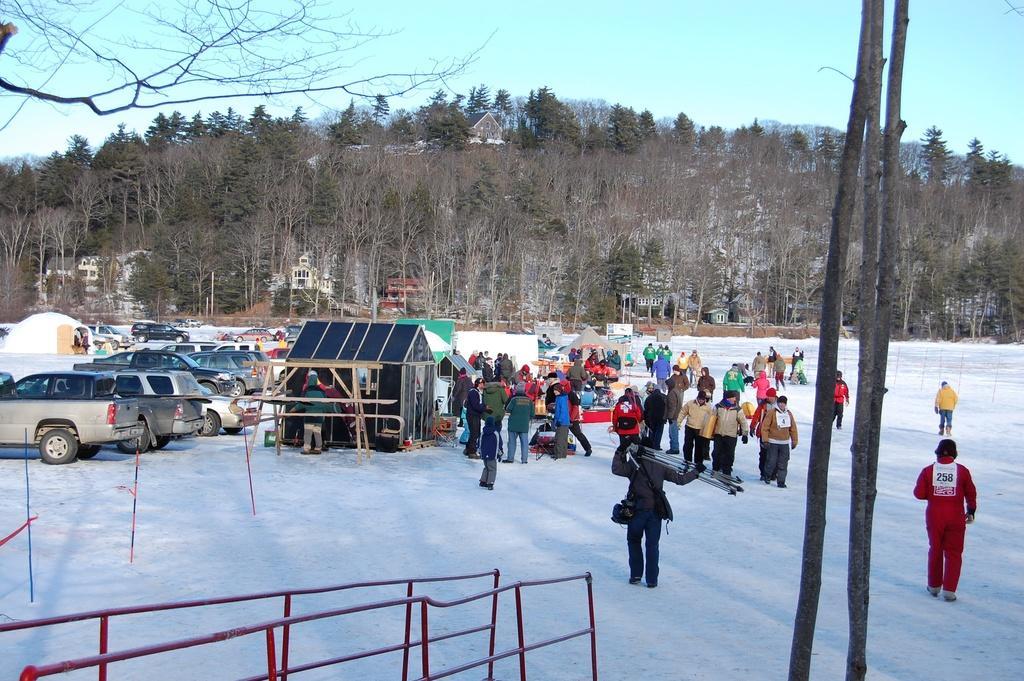Describe this image in one or two sentences. In the image we can see there are many people standing and some of them are walking. They are wearing clothes, shoes and some of them are wearing caps. Everywhere there is snow, white in color. Here we can see fence and vehicles. We can even see there are buildings, trees and the sky. 